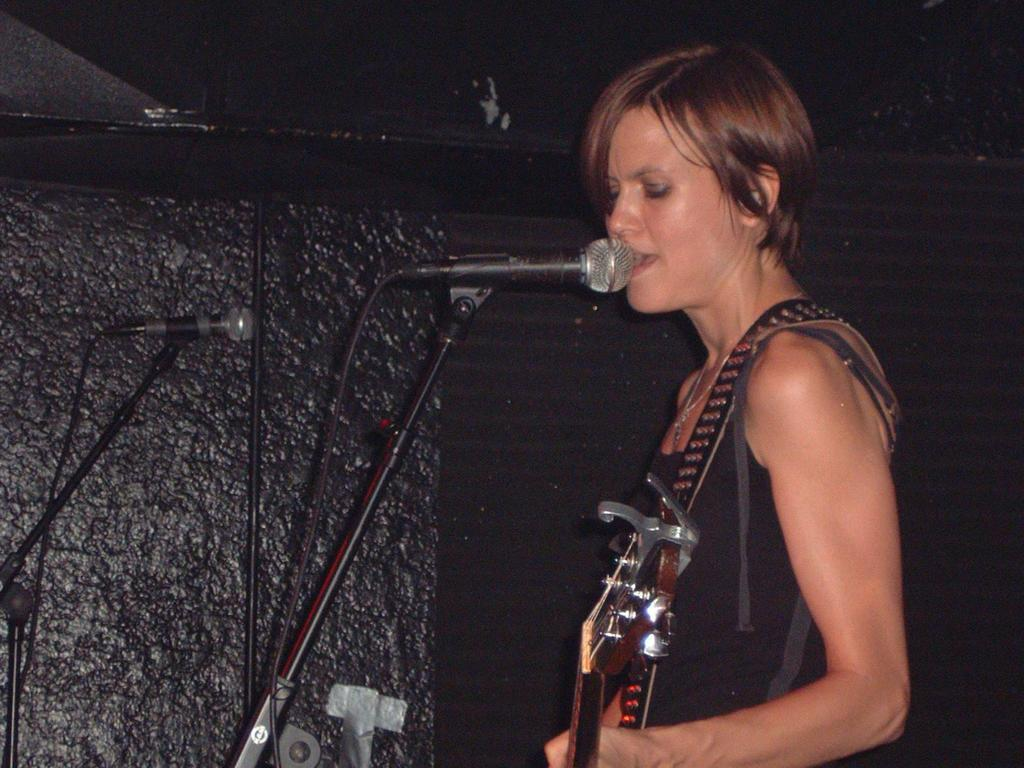What is the main subject of the image? The main subject of the image is a woman. What is the woman doing in the image? The woman is standing and singing a song. What instrument is the woman associated with in the image? The woman is wearing a guitar around her shoulder. What color is the wall in the background of the image? The wall in the background of the image is black. How many corks are visible on the woman's outfit in the image? There are no corks visible on the woman's outfit in the image. What type of yoke is the woman using to sing the song? The woman is not using a yoke to sing the song; she is simply singing. 